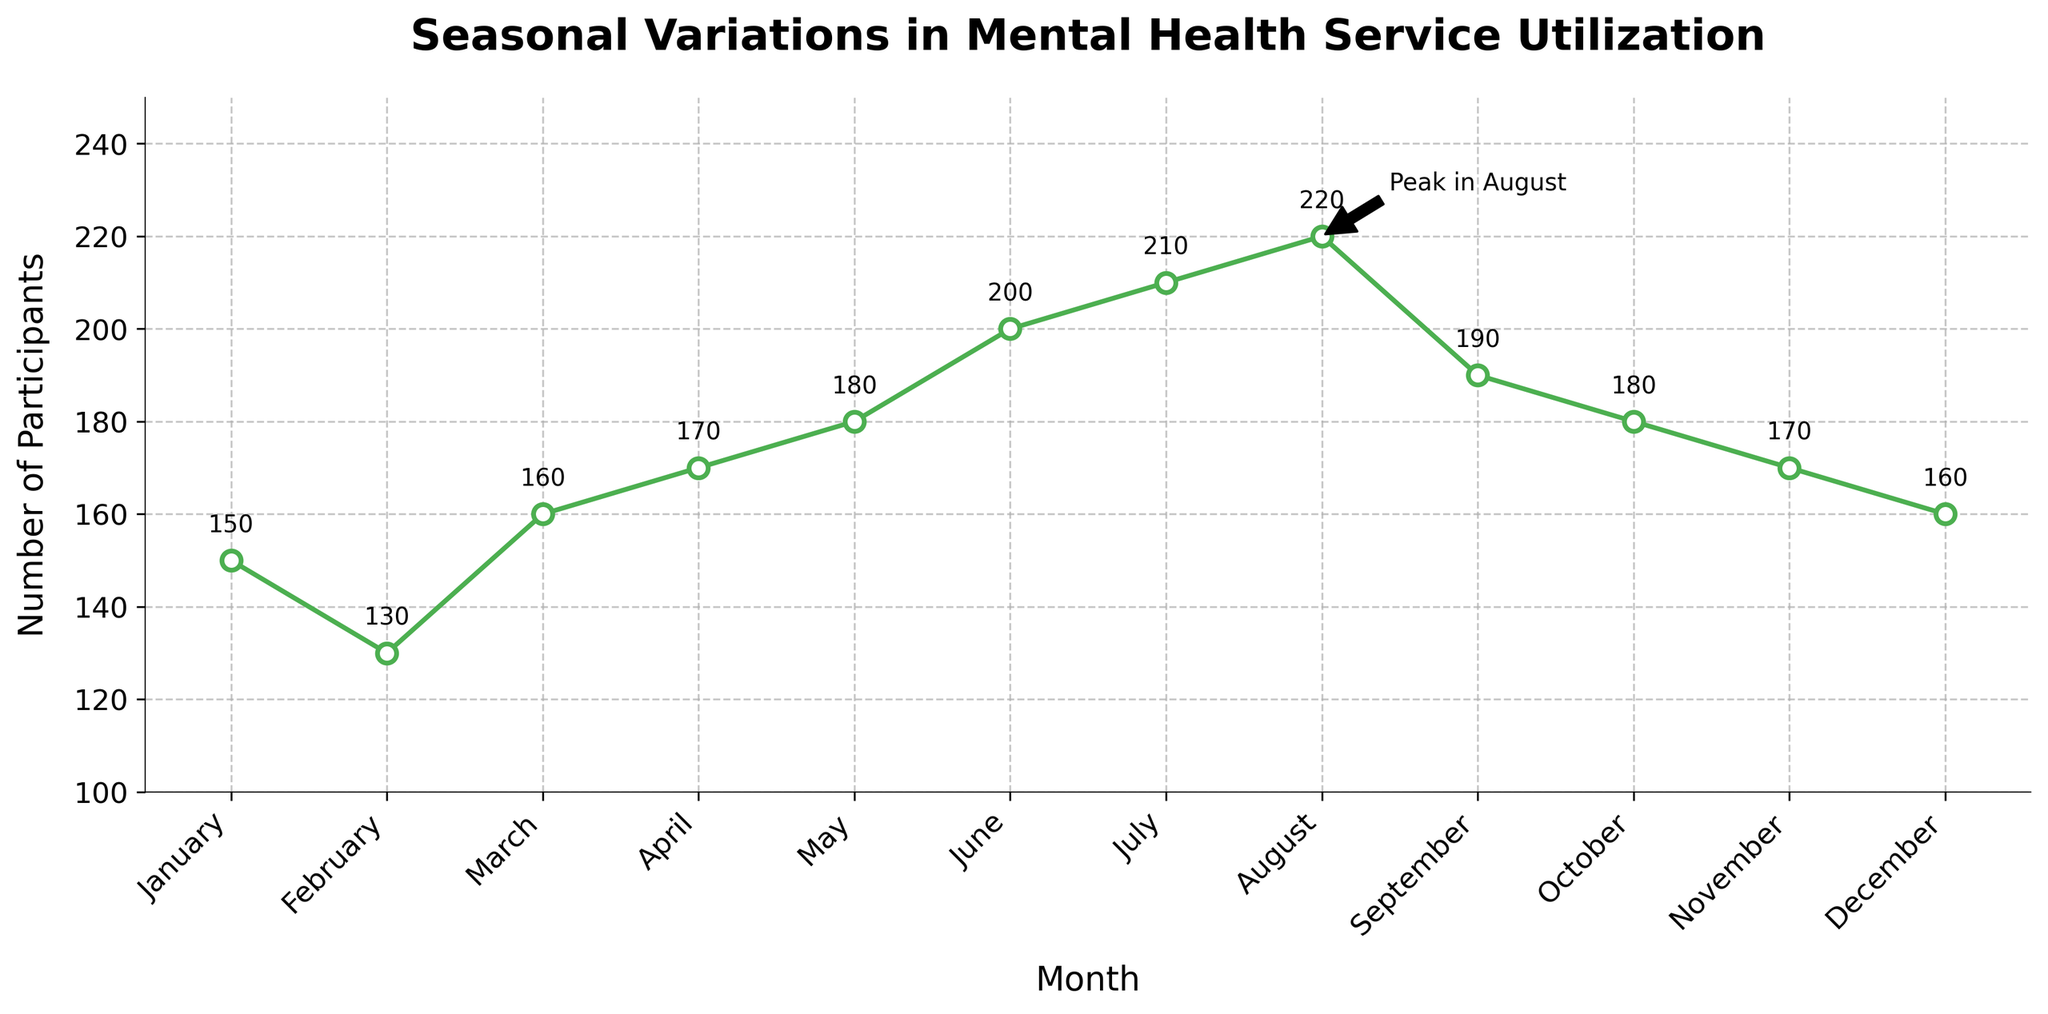What is the highest number of participants utilizing mental health services in a month? The highest number is found where the data point is annotated 'Peak in August', showing a value of 220 participants.
Answer: 220 What is the total number of participants utilizing mental health services over the entire year? Sum all the monthly values: 150 + 130 + 160 + 170 + 180 + 200 + 210 + 220 + 190 + 180 + 170 + 160 = 2220.
Answer: 2220 What month has the minimum number of participants utilizing mental health services? The month with the lowest number is February, which has 130 participants.
Answer: February Which months show a steady increase in the participants utilizing mental health services? From February to August, the number of participants increases continuously: February (130), March (160), April (170), May (180), June (200), July (210), August (220).
Answer: February to August How does the number of participants in July compare to that in January? The number of participants in January is 150, and in July, it's 210. Thus, July has 60 more participants than January.
Answer: 60 more What is the numerical difference in participants between the highest and lowest months? The highest month is August (220 participants), and the lowest month is February (130 participants). The difference is 220 - 130 = 90.
Answer: 90 What is the average number of participants utilizing mental health services per month? Calculate the average by dividing the total yearly participants by 12: 2220 / 12 = 185 participants.
Answer: 185 How many months have at least 200 participants utilizing mental health services? The months are June (200), July (210), and August (220), so there are 3 such months.
Answer: 3 What's the trend in the number of participants from September to December? In September, there are 190 participants, October has 180, November has 170, and December has 160, indicating a decreasing trend.
Answer: Decreasing Which months have exactly 170 participants utilizing mental health services? The months with 170 participants are April and November.
Answer: April and November 